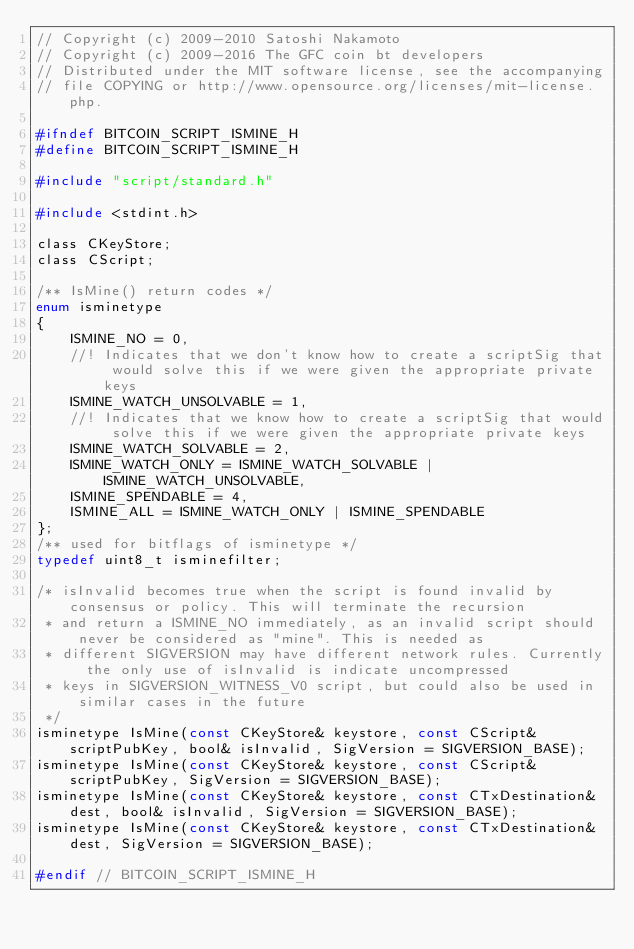<code> <loc_0><loc_0><loc_500><loc_500><_C_>// Copyright (c) 2009-2010 Satoshi Nakamoto
// Copyright (c) 2009-2016 The GFC coin bt developers
// Distributed under the MIT software license, see the accompanying
// file COPYING or http://www.opensource.org/licenses/mit-license.php.

#ifndef BITCOIN_SCRIPT_ISMINE_H
#define BITCOIN_SCRIPT_ISMINE_H

#include "script/standard.h"

#include <stdint.h>

class CKeyStore;
class CScript;

/** IsMine() return codes */
enum isminetype
{
    ISMINE_NO = 0,
    //! Indicates that we don't know how to create a scriptSig that would solve this if we were given the appropriate private keys
    ISMINE_WATCH_UNSOLVABLE = 1,
    //! Indicates that we know how to create a scriptSig that would solve this if we were given the appropriate private keys
    ISMINE_WATCH_SOLVABLE = 2,
    ISMINE_WATCH_ONLY = ISMINE_WATCH_SOLVABLE | ISMINE_WATCH_UNSOLVABLE,
    ISMINE_SPENDABLE = 4,
    ISMINE_ALL = ISMINE_WATCH_ONLY | ISMINE_SPENDABLE
};
/** used for bitflags of isminetype */
typedef uint8_t isminefilter;

/* isInvalid becomes true when the script is found invalid by consensus or policy. This will terminate the recursion
 * and return a ISMINE_NO immediately, as an invalid script should never be considered as "mine". This is needed as
 * different SIGVERSION may have different network rules. Currently the only use of isInvalid is indicate uncompressed
 * keys in SIGVERSION_WITNESS_V0 script, but could also be used in similar cases in the future
 */
isminetype IsMine(const CKeyStore& keystore, const CScript& scriptPubKey, bool& isInvalid, SigVersion = SIGVERSION_BASE);
isminetype IsMine(const CKeyStore& keystore, const CScript& scriptPubKey, SigVersion = SIGVERSION_BASE);
isminetype IsMine(const CKeyStore& keystore, const CTxDestination& dest, bool& isInvalid, SigVersion = SIGVERSION_BASE);
isminetype IsMine(const CKeyStore& keystore, const CTxDestination& dest, SigVersion = SIGVERSION_BASE);

#endif // BITCOIN_SCRIPT_ISMINE_H
</code> 